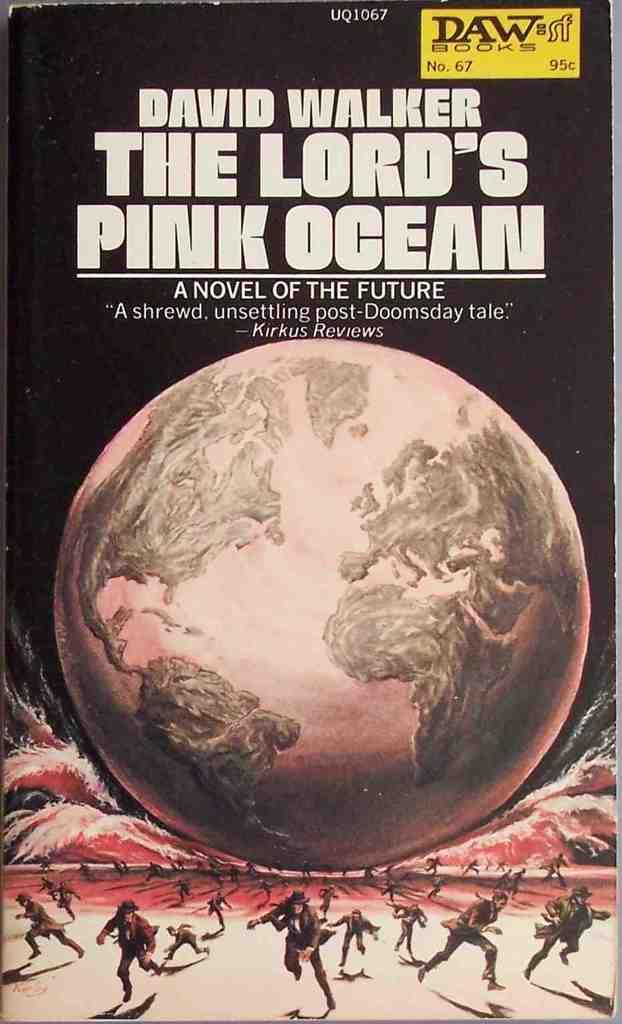<image>
Write a terse but informative summary of the picture. A book titled the lord's pink ocean by David Walker. 